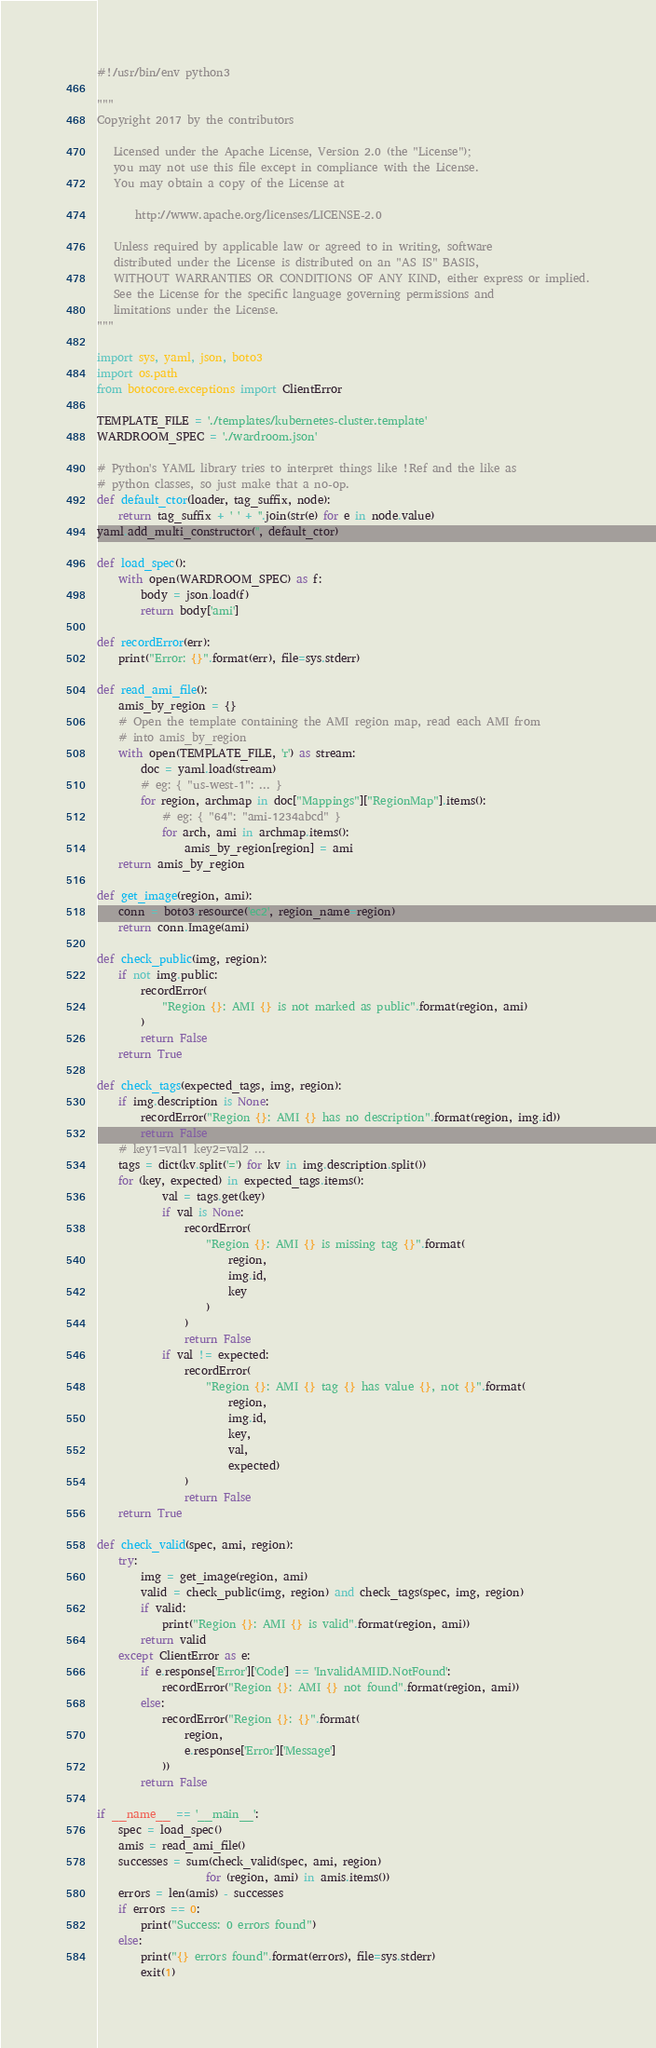<code> <loc_0><loc_0><loc_500><loc_500><_Python_>#!/usr/bin/env python3

"""
Copyright 2017 by the contributors

   Licensed under the Apache License, Version 2.0 (the "License");
   you may not use this file except in compliance with the License.
   You may obtain a copy of the License at

       http://www.apache.org/licenses/LICENSE-2.0

   Unless required by applicable law or agreed to in writing, software
   distributed under the License is distributed on an "AS IS" BASIS,
   WITHOUT WARRANTIES OR CONDITIONS OF ANY KIND, either express or implied.
   See the License for the specific language governing permissions and
   limitations under the License.
"""

import sys, yaml, json, boto3
import os.path
from botocore.exceptions import ClientError

TEMPLATE_FILE = './templates/kubernetes-cluster.template'
WARDROOM_SPEC = './wardroom.json'

# Python's YAML library tries to interpret things like !Ref and the like as
# python classes, so just make that a no-op.
def default_ctor(loader, tag_suffix, node):
    return tag_suffix + ' ' + ''.join(str(e) for e in node.value)
yaml.add_multi_constructor('', default_ctor)

def load_spec():
    with open(WARDROOM_SPEC) as f:
        body = json.load(f)
        return body['ami']

def recordError(err):
    print("Error: {}".format(err), file=sys.stderr)

def read_ami_file():
    amis_by_region = {}
    # Open the template containing the AMI region map, read each AMI from
    # into amis_by_region
    with open(TEMPLATE_FILE, 'r') as stream:
        doc = yaml.load(stream)
        # eg: { "us-west-1": ... }
        for region, archmap in doc["Mappings"]["RegionMap"].items():
            # eg: { "64": "ami-1234abcd" }
            for arch, ami in archmap.items():
                amis_by_region[region] = ami
    return amis_by_region

def get_image(region, ami):
    conn = boto3.resource('ec2', region_name=region)
    return conn.Image(ami)

def check_public(img, region):
    if not img.public:
        recordError(
            "Region {}: AMI {} is not marked as public".format(region, ami)
        )
        return False
    return True

def check_tags(expected_tags, img, region):
    if img.description is None:
        recordError("Region {}: AMI {} has no description".format(region, img.id))
        return False
    # key1=val1 key2=val2 ...
    tags = dict(kv.split('=') for kv in img.description.split())
    for (key, expected) in expected_tags.items():
            val = tags.get(key) 
            if val is None:
                recordError(
                    "Region {}: AMI {} is missing tag {}".format(
                        region,
                        img.id,
                        key
                    )
                )
                return False
            if val != expected:
                recordError(
                    "Region {}: AMI {} tag {} has value {}, not {}".format(
                        region,
                        img.id,
                        key,
                        val,
                        expected)
                )
                return False
    return True

def check_valid(spec, ami, region):
    try:
        img = get_image(region, ami)
        valid = check_public(img, region) and check_tags(spec, img, region)
        if valid:
            print("Region {}: AMI {} is valid".format(region, ami))
        return valid
    except ClientError as e:
        if e.response['Error']['Code'] == 'InvalidAMIID.NotFound':
            recordError("Region {}: AMI {} not found".format(region, ami))
        else:
            recordError("Region {}: {}".format(
                region,
                e.response['Error']['Message']
            ))
        return False

if __name__ == '__main__':
    spec = load_spec()
    amis = read_ami_file()
    successes = sum(check_valid(spec, ami, region)
                    for (region, ami) in amis.items())
    errors = len(amis) - successes
    if errors == 0:
        print("Success: 0 errors found")
    else:
        print("{} errors found".format(errors), file=sys.stderr)
        exit(1)
</code> 